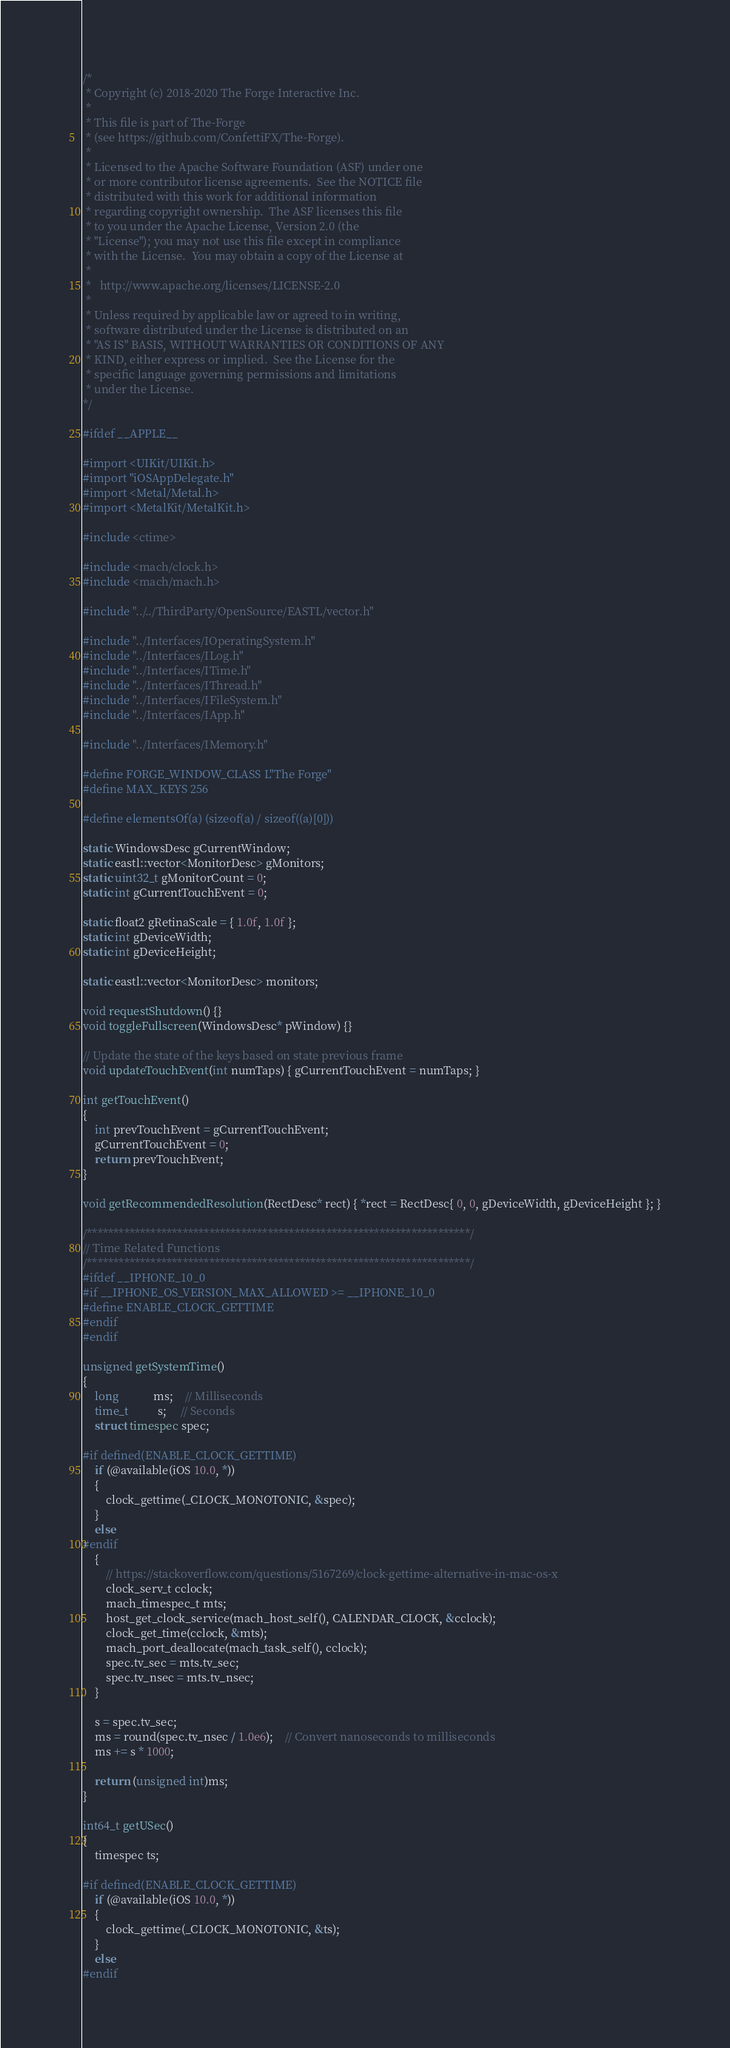Convert code to text. <code><loc_0><loc_0><loc_500><loc_500><_ObjectiveC_>/*
 * Copyright (c) 2018-2020 The Forge Interactive Inc.
 *
 * This file is part of The-Forge
 * (see https://github.com/ConfettiFX/The-Forge).
 *
 * Licensed to the Apache Software Foundation (ASF) under one
 * or more contributor license agreements.  See the NOTICE file
 * distributed with this work for additional information
 * regarding copyright ownership.  The ASF licenses this file
 * to you under the Apache License, Version 2.0 (the
 * "License"); you may not use this file except in compliance
 * with the License.  You may obtain a copy of the License at
 *
 *   http://www.apache.org/licenses/LICENSE-2.0
 *
 * Unless required by applicable law or agreed to in writing,
 * software distributed under the License is distributed on an
 * "AS IS" BASIS, WITHOUT WARRANTIES OR CONDITIONS OF ANY
 * KIND, either express or implied.  See the License for the
 * specific language governing permissions and limitations
 * under the License.
*/

#ifdef __APPLE__

#import <UIKit/UIKit.h>
#import "iOSAppDelegate.h"
#import <Metal/Metal.h>
#import <MetalKit/MetalKit.h>

#include <ctime>

#include <mach/clock.h>
#include <mach/mach.h>

#include "../../ThirdParty/OpenSource/EASTL/vector.h"

#include "../Interfaces/IOperatingSystem.h"
#include "../Interfaces/ILog.h"
#include "../Interfaces/ITime.h"
#include "../Interfaces/IThread.h"
#include "../Interfaces/IFileSystem.h"
#include "../Interfaces/IApp.h"

#include "../Interfaces/IMemory.h"

#define FORGE_WINDOW_CLASS L"The Forge"
#define MAX_KEYS 256

#define elementsOf(a) (sizeof(a) / sizeof((a)[0]))

static WindowsDesc gCurrentWindow;
static eastl::vector<MonitorDesc> gMonitors;
static uint32_t gMonitorCount = 0;
static int gCurrentTouchEvent = 0;

static float2 gRetinaScale = { 1.0f, 1.0f };
static int gDeviceWidth;
static int gDeviceHeight;

static eastl::vector<MonitorDesc> monitors;

void requestShutdown() {}
void toggleFullscreen(WindowsDesc* pWindow) {}

// Update the state of the keys based on state previous frame
void updateTouchEvent(int numTaps) { gCurrentTouchEvent = numTaps; }

int getTouchEvent()
{
	int prevTouchEvent = gCurrentTouchEvent;
	gCurrentTouchEvent = 0;
	return prevTouchEvent;
}

void getRecommendedResolution(RectDesc* rect) { *rect = RectDesc{ 0, 0, gDeviceWidth, gDeviceHeight }; }

/************************************************************************/
// Time Related Functions
/************************************************************************/
#ifdef __IPHONE_10_0
#if __IPHONE_OS_VERSION_MAX_ALLOWED >= __IPHONE_10_0
#define ENABLE_CLOCK_GETTIME
#endif
#endif

unsigned getSystemTime()
{
	long            ms;    // Milliseconds
	time_t          s;     // Seconds
	struct timespec spec;
	
#if defined(ENABLE_CLOCK_GETTIME)
	if (@available(iOS 10.0, *))
	{
		clock_gettime(_CLOCK_MONOTONIC, &spec);
	}
	else
#endif
	{
		// https://stackoverflow.com/questions/5167269/clock-gettime-alternative-in-mac-os-x
		clock_serv_t cclock;
		mach_timespec_t mts;
		host_get_clock_service(mach_host_self(), CALENDAR_CLOCK, &cclock);
		clock_get_time(cclock, &mts);
		mach_port_deallocate(mach_task_self(), cclock);
		spec.tv_sec = mts.tv_sec;
		spec.tv_nsec = mts.tv_nsec;
	}
	
	s = spec.tv_sec;
	ms = round(spec.tv_nsec / 1.0e6);    // Convert nanoseconds to milliseconds
	ms += s * 1000;

	return (unsigned int)ms;
}

int64_t getUSec()
{
	timespec ts;
	
#if defined(ENABLE_CLOCK_GETTIME)
	if (@available(iOS 10.0, *))
	{
		clock_gettime(_CLOCK_MONOTONIC, &ts);
	}
	else
#endif</code> 